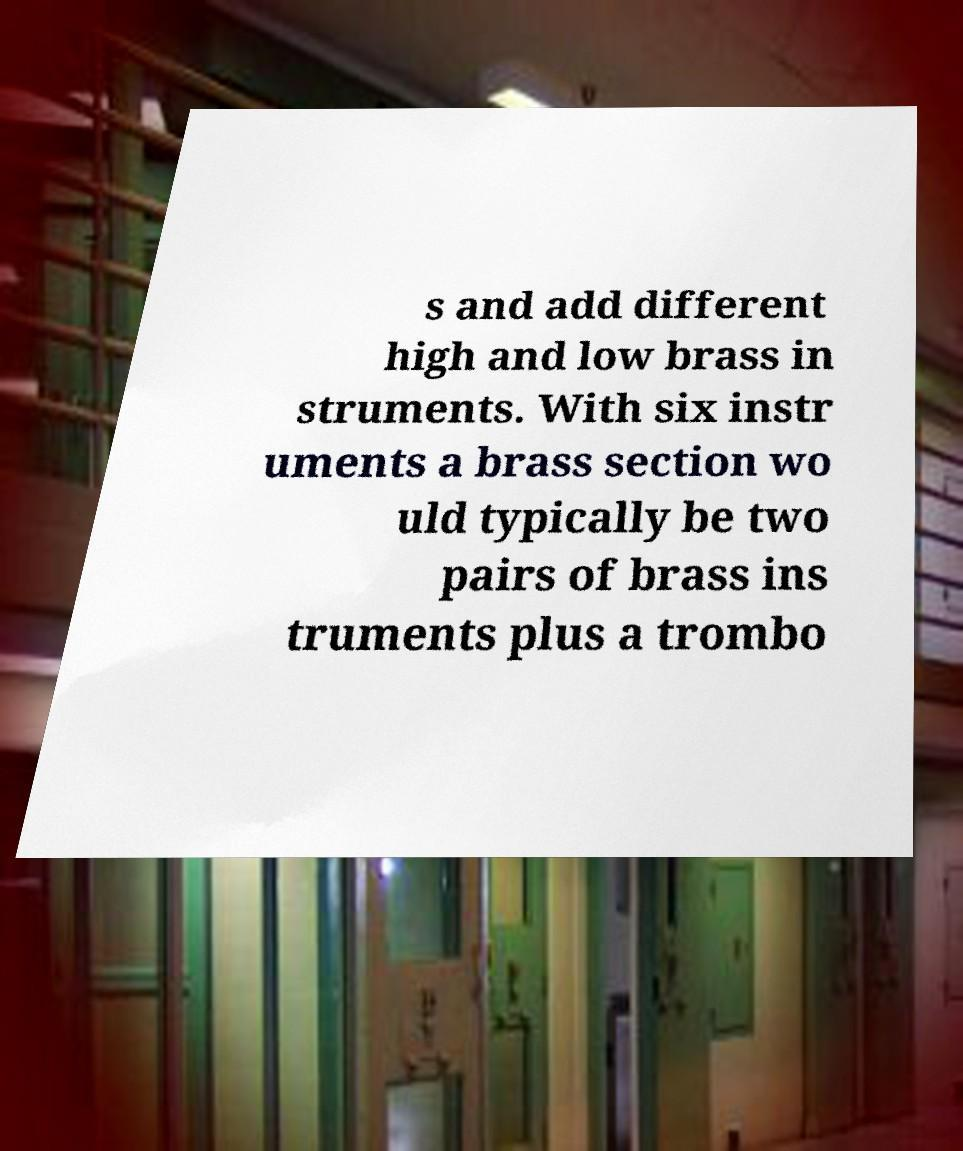Please identify and transcribe the text found in this image. s and add different high and low brass in struments. With six instr uments a brass section wo uld typically be two pairs of brass ins truments plus a trombo 